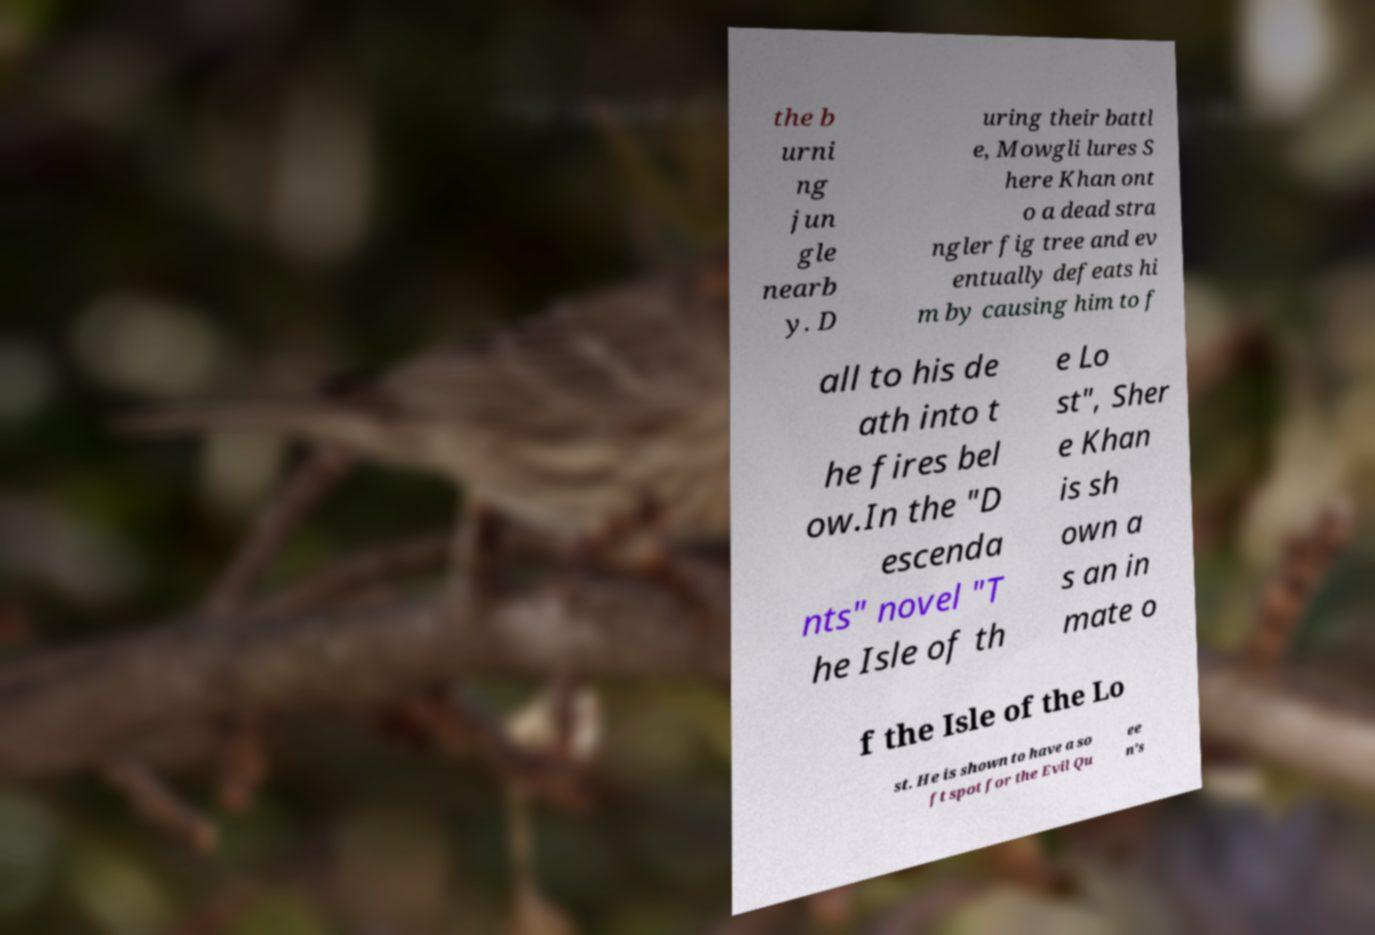I need the written content from this picture converted into text. Can you do that? the b urni ng jun gle nearb y. D uring their battl e, Mowgli lures S here Khan ont o a dead stra ngler fig tree and ev entually defeats hi m by causing him to f all to his de ath into t he fires bel ow.In the "D escenda nts" novel "T he Isle of th e Lo st", Sher e Khan is sh own a s an in mate o f the Isle of the Lo st. He is shown to have a so ft spot for the Evil Qu ee n's 